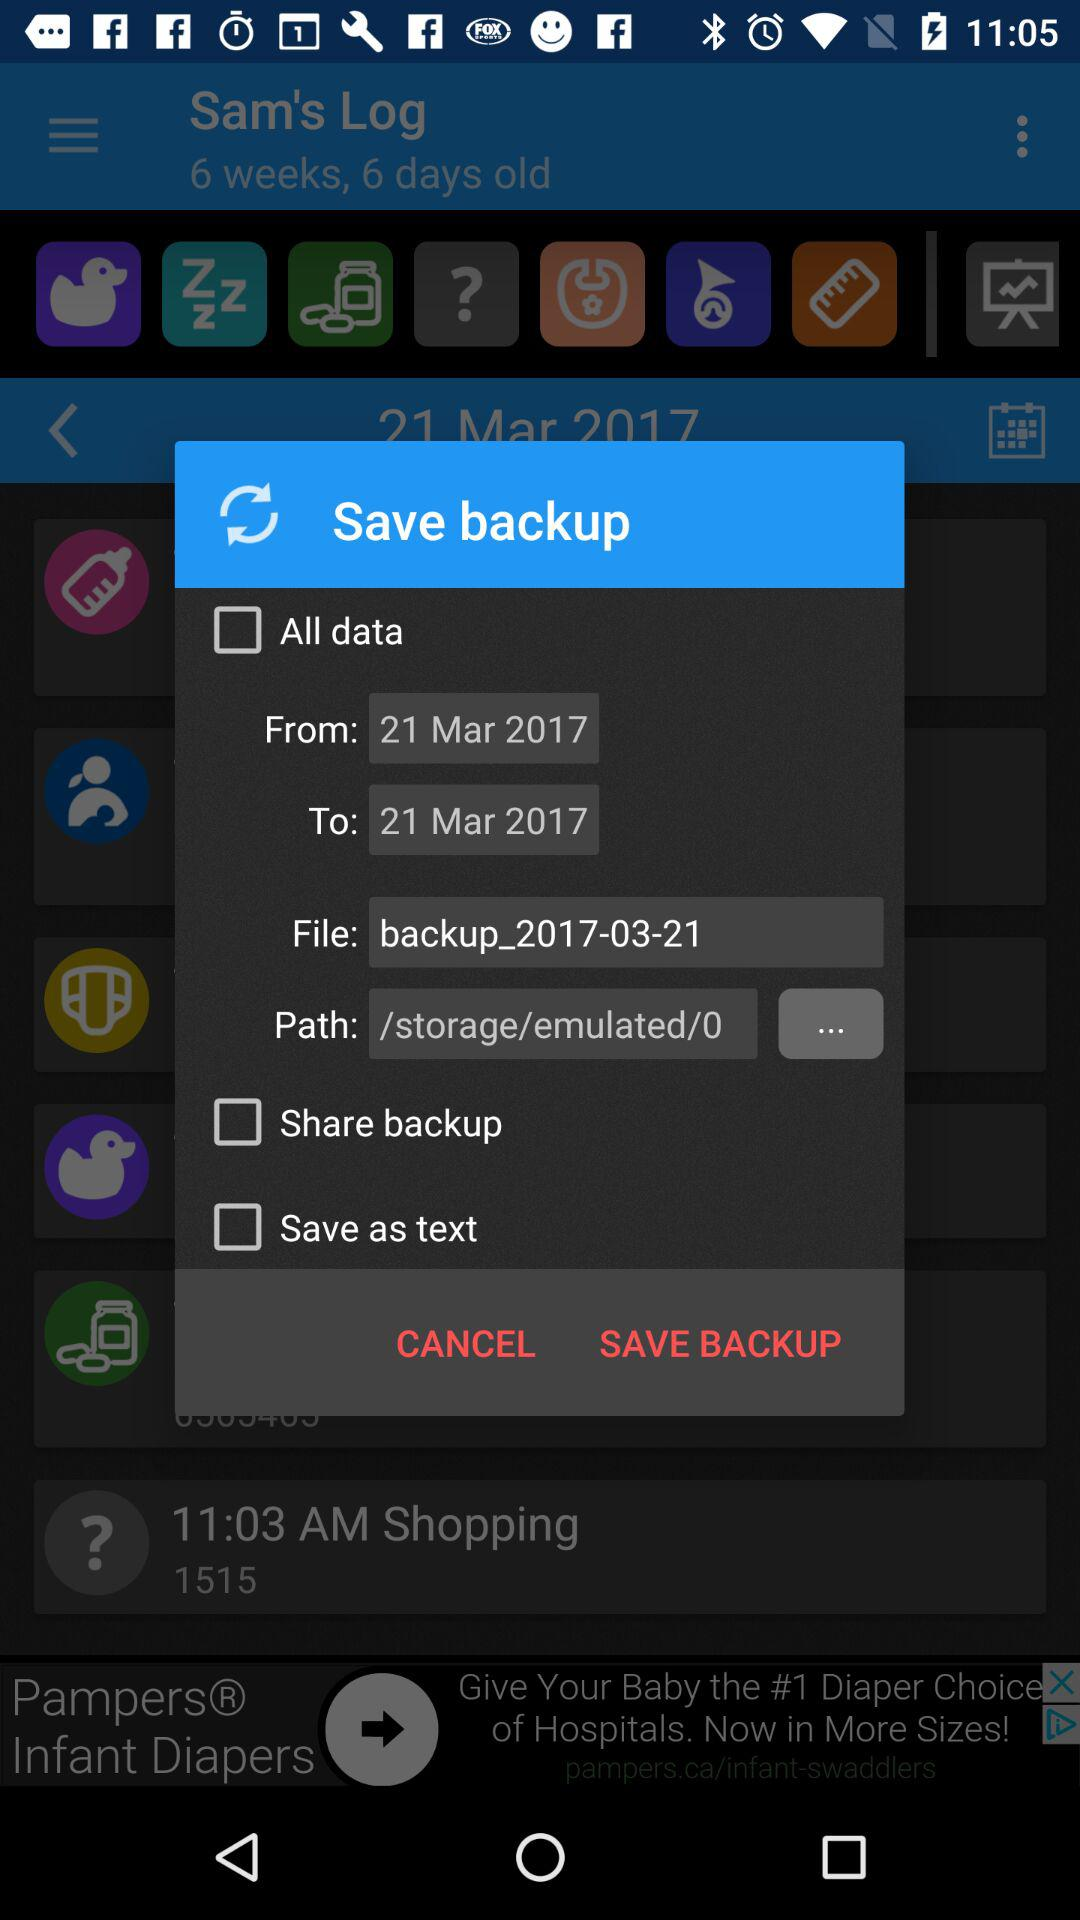What exactly is the path address? The path address is "/storage/emulated/0". 